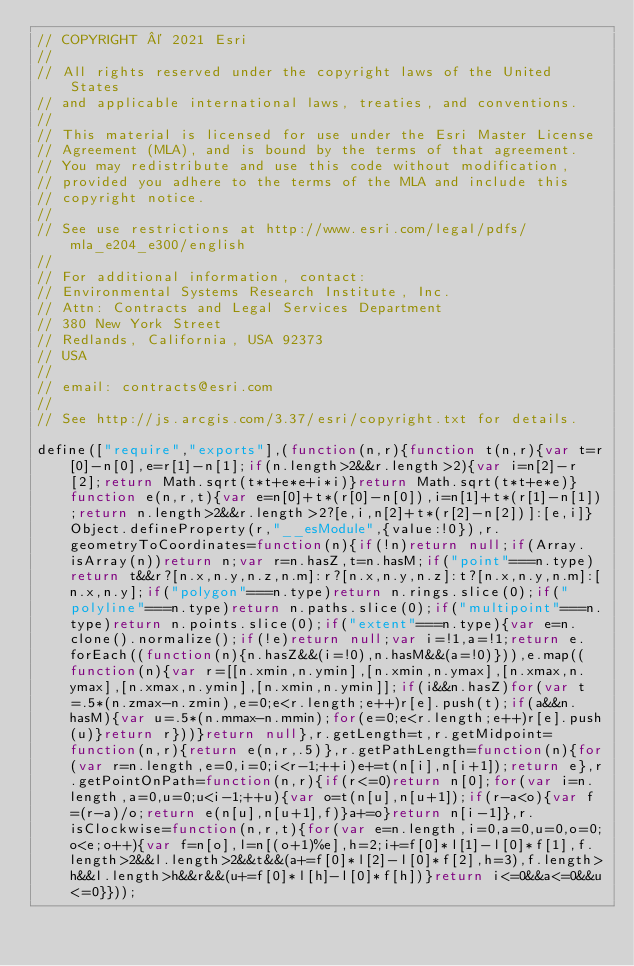Convert code to text. <code><loc_0><loc_0><loc_500><loc_500><_JavaScript_>// COPYRIGHT © 2021 Esri
//
// All rights reserved under the copyright laws of the United States
// and applicable international laws, treaties, and conventions.
//
// This material is licensed for use under the Esri Master License
// Agreement (MLA), and is bound by the terms of that agreement.
// You may redistribute and use this code without modification,
// provided you adhere to the terms of the MLA and include this
// copyright notice.
//
// See use restrictions at http://www.esri.com/legal/pdfs/mla_e204_e300/english
//
// For additional information, contact:
// Environmental Systems Research Institute, Inc.
// Attn: Contracts and Legal Services Department
// 380 New York Street
// Redlands, California, USA 92373
// USA
//
// email: contracts@esri.com
//
// See http://js.arcgis.com/3.37/esri/copyright.txt for details.

define(["require","exports"],(function(n,r){function t(n,r){var t=r[0]-n[0],e=r[1]-n[1];if(n.length>2&&r.length>2){var i=n[2]-r[2];return Math.sqrt(t*t+e*e+i*i)}return Math.sqrt(t*t+e*e)}function e(n,r,t){var e=n[0]+t*(r[0]-n[0]),i=n[1]+t*(r[1]-n[1]);return n.length>2&&r.length>2?[e,i,n[2]+t*(r[2]-n[2])]:[e,i]}Object.defineProperty(r,"__esModule",{value:!0}),r.geometryToCoordinates=function(n){if(!n)return null;if(Array.isArray(n))return n;var r=n.hasZ,t=n.hasM;if("point"===n.type)return t&&r?[n.x,n.y,n.z,n.m]:r?[n.x,n.y,n.z]:t?[n.x,n.y,n.m]:[n.x,n.y];if("polygon"===n.type)return n.rings.slice(0);if("polyline"===n.type)return n.paths.slice(0);if("multipoint"===n.type)return n.points.slice(0);if("extent"===n.type){var e=n.clone().normalize();if(!e)return null;var i=!1,a=!1;return e.forEach((function(n){n.hasZ&&(i=!0),n.hasM&&(a=!0)})),e.map((function(n){var r=[[n.xmin,n.ymin],[n.xmin,n.ymax],[n.xmax,n.ymax],[n.xmax,n.ymin],[n.xmin,n.ymin]];if(i&&n.hasZ)for(var t=.5*(n.zmax-n.zmin),e=0;e<r.length;e++)r[e].push(t);if(a&&n.hasM){var u=.5*(n.mmax-n.mmin);for(e=0;e<r.length;e++)r[e].push(u)}return r}))}return null},r.getLength=t,r.getMidpoint=function(n,r){return e(n,r,.5)},r.getPathLength=function(n){for(var r=n.length,e=0,i=0;i<r-1;++i)e+=t(n[i],n[i+1]);return e},r.getPointOnPath=function(n,r){if(r<=0)return n[0];for(var i=n.length,a=0,u=0;u<i-1;++u){var o=t(n[u],n[u+1]);if(r-a<o){var f=(r-a)/o;return e(n[u],n[u+1],f)}a+=o}return n[i-1]},r.isClockwise=function(n,r,t){for(var e=n.length,i=0,a=0,u=0,o=0;o<e;o++){var f=n[o],l=n[(o+1)%e],h=2;i+=f[0]*l[1]-l[0]*f[1],f.length>2&&l.length>2&&t&&(a+=f[0]*l[2]-l[0]*f[2],h=3),f.length>h&&l.length>h&&r&&(u+=f[0]*l[h]-l[0]*f[h])}return i<=0&&a<=0&&u<=0}}));</code> 